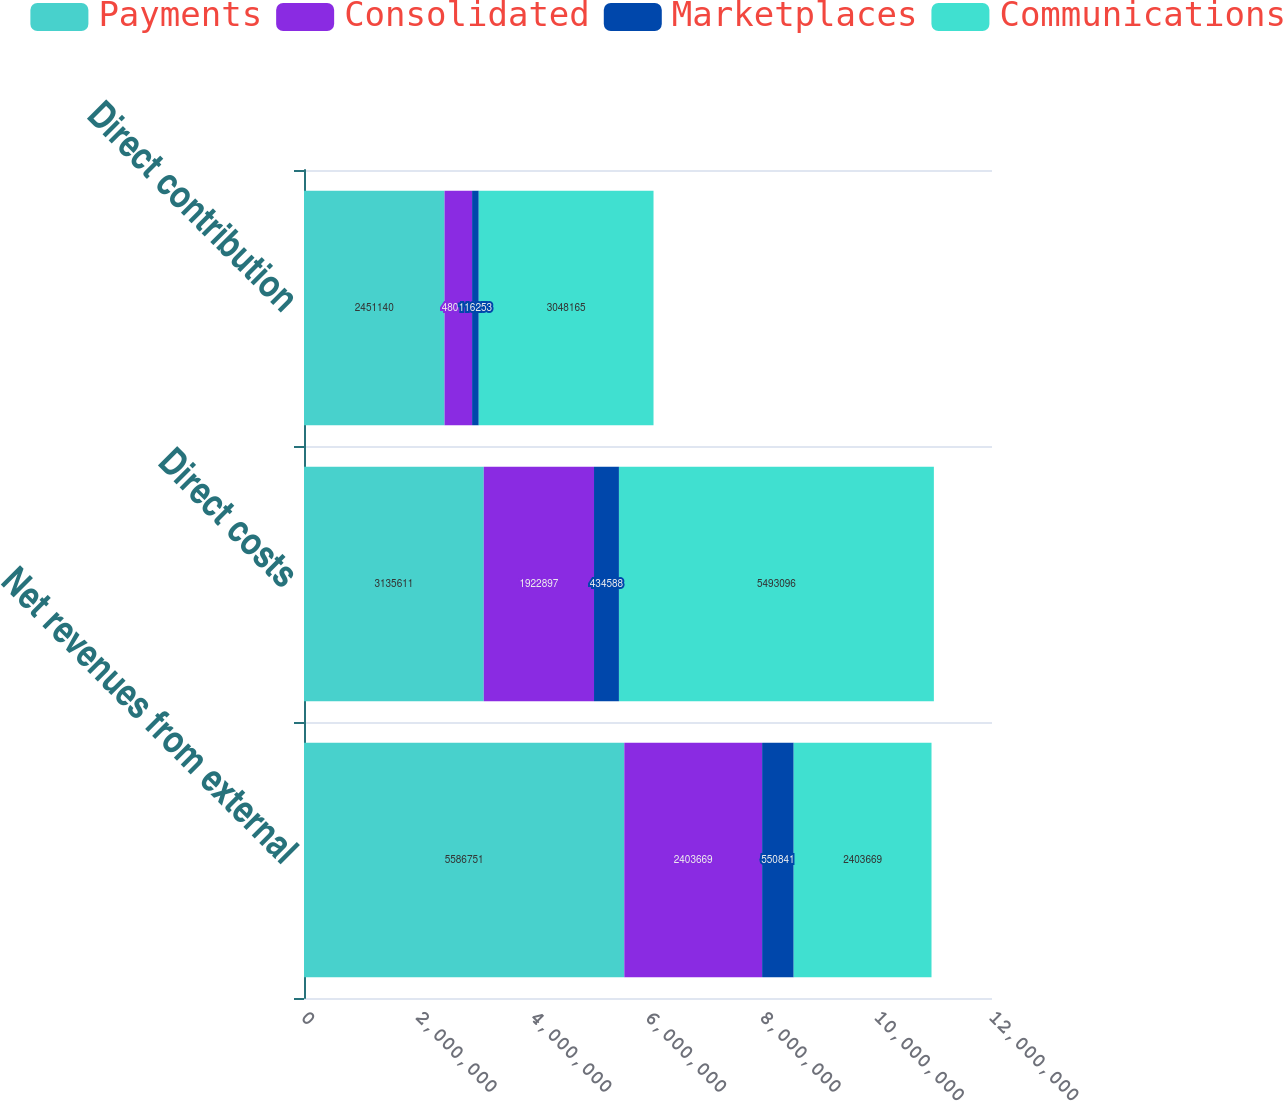Convert chart to OTSL. <chart><loc_0><loc_0><loc_500><loc_500><stacked_bar_chart><ecel><fcel>Net revenues from external<fcel>Direct costs<fcel>Direct contribution<nl><fcel>Payments<fcel>5.58675e+06<fcel>3.13561e+06<fcel>2.45114e+06<nl><fcel>Consolidated<fcel>2.40367e+06<fcel>1.9229e+06<fcel>480772<nl><fcel>Marketplaces<fcel>550841<fcel>434588<fcel>116253<nl><fcel>Communications<fcel>2.40367e+06<fcel>5.4931e+06<fcel>3.04816e+06<nl></chart> 